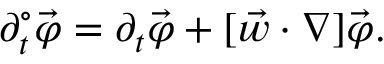Convert formula to latex. <formula><loc_0><loc_0><loc_500><loc_500>\partial _ { t } ^ { \circ } \vec { \varphi } = \partial _ { t } \vec { \varphi } + [ \vec { w } \cdot \nabla ] \vec { \varphi } .</formula> 